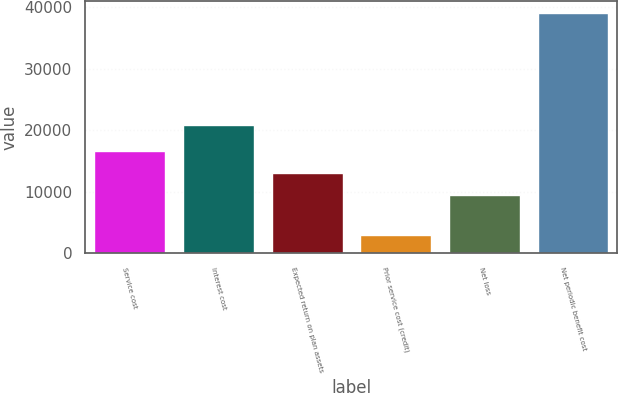Convert chart to OTSL. <chart><loc_0><loc_0><loc_500><loc_500><bar_chart><fcel>Service cost<fcel>Interest cost<fcel>Expected return on plan assets<fcel>Prior service cost (credit)<fcel>Net loss<fcel>Net periodic benefit cost<nl><fcel>16625.8<fcel>20774<fcel>13009.9<fcel>2914<fcel>9394<fcel>39073<nl></chart> 